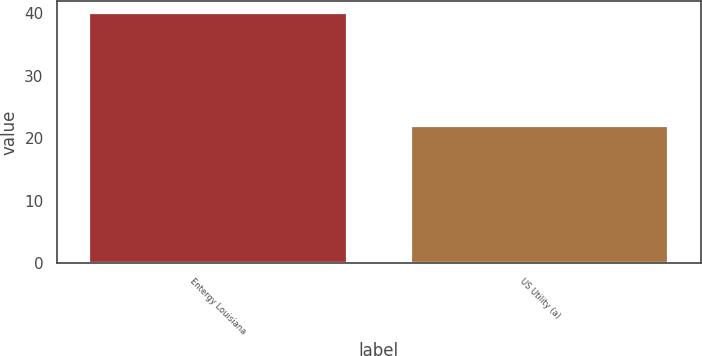Convert chart to OTSL. <chart><loc_0><loc_0><loc_500><loc_500><bar_chart><fcel>Entergy Louisiana<fcel>US Utility (a)<nl><fcel>40<fcel>22<nl></chart> 